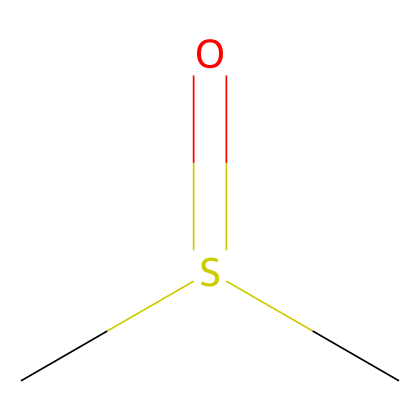How many carbon atoms are present in dimethyl sulfoxide? The SMILES representation shows "CS(=O)C", which indicates there are two "C" symbols present, each representing a carbon atom.
Answer: 2 What functional group is present in dimethyl sulfoxide? The "S(=O)" part of the SMILES indicates the presence of a sulfoxide functional group, where sulfur is bonded to oxygen by a double bond.
Answer: sulfoxide How many total hydrogen atoms are in dimethyl sulfoxide? Each carbon in dimethyl sulfoxide is bonded to three hydrogen atoms in total (C2H6O), with one hydrogen replaced by the sulfoxide group, yielding a total of six hydrogen atoms.
Answer: 6 What is the oxidation state of sulfur in dimethyl sulfoxide? In the structure, sulfur is bonded to one oxygen with a double bond (C=S) and connected to carbon atoms. Given the bonding, sulfur in this compound has an oxidation state of +4.
Answer: +4 Is dimethyl sulfoxide polar or nonpolar? The presence of the sulfoxide group creates a dipole moment due to the electronegativity difference between sulfur and oxygen, making dimethyl sulfoxide a polar solvent.
Answer: polar What is the molecular weight of dimethyl sulfoxide? The molecular formula derived from the SMILES representation is C2H6OS, where the molecular weight is calculated by summing the atomic weights: (2 x 12.01) + (6 x 1.008) + (32.07) = 78.13 g/mol.
Answer: 78.13 